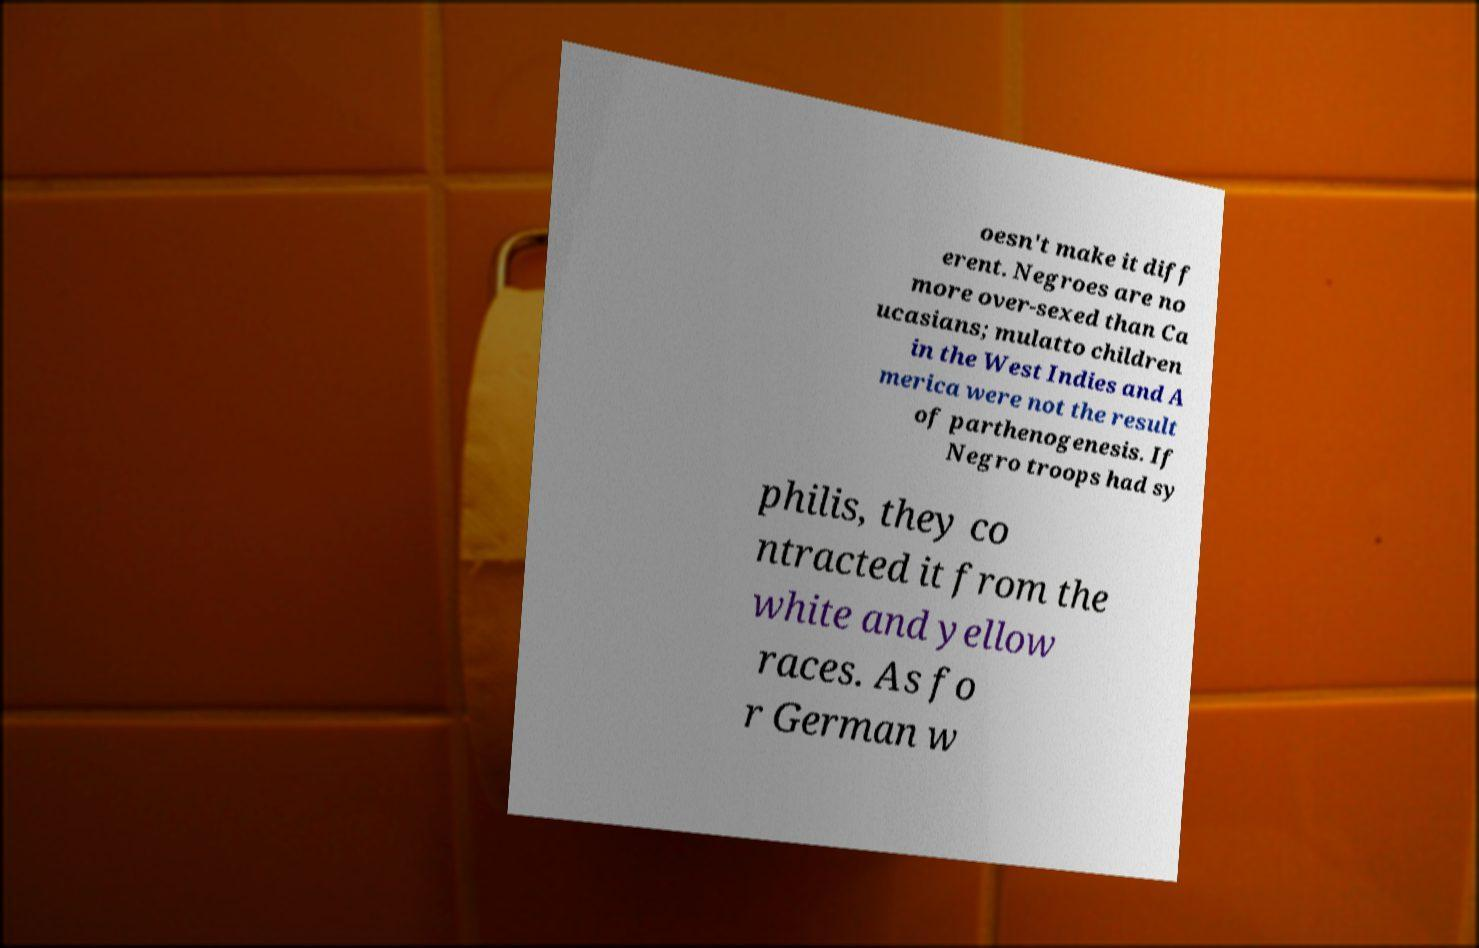For documentation purposes, I need the text within this image transcribed. Could you provide that? oesn't make it diff erent. Negroes are no more over-sexed than Ca ucasians; mulatto children in the West Indies and A merica were not the result of parthenogenesis. If Negro troops had sy philis, they co ntracted it from the white and yellow races. As fo r German w 